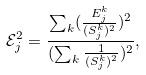<formula> <loc_0><loc_0><loc_500><loc_500>\mathcal { E } _ { j } ^ { 2 } = \frac { \sum _ { k } ( \frac { E _ { j } ^ { k } } { ( S _ { j } ^ { k } ) ^ { 2 } } ) ^ { 2 } } { ( \sum _ { k } \frac { 1 } { ( S _ { j } ^ { k } ) ^ { 2 } } ) ^ { 2 } } ,</formula> 